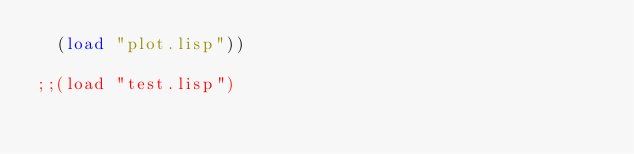Convert code to text. <code><loc_0><loc_0><loc_500><loc_500><_Lisp_>  (load "plot.lisp"))

;;(load "test.lisp")
</code> 